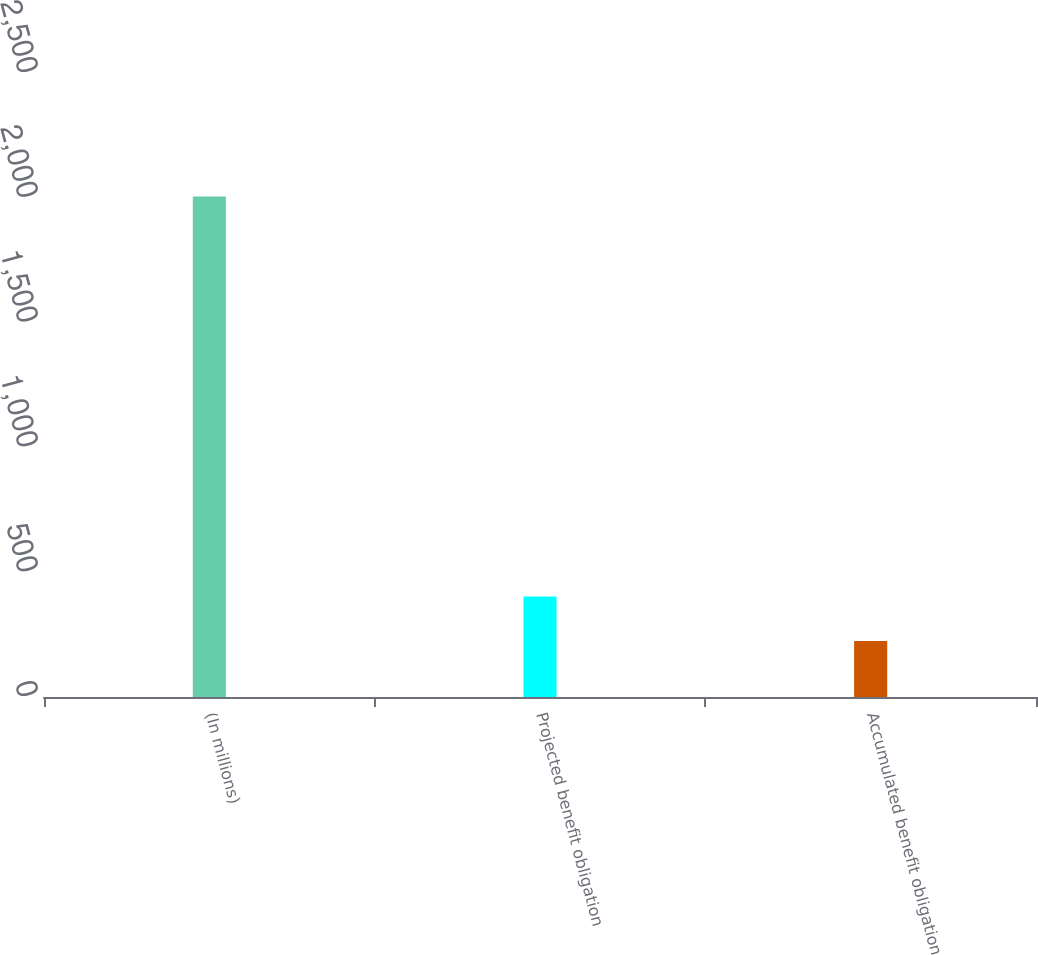<chart> <loc_0><loc_0><loc_500><loc_500><bar_chart><fcel>(In millions)<fcel>Projected benefit obligation<fcel>Accumulated benefit obligation<nl><fcel>2005<fcel>402.19<fcel>224.1<nl></chart> 